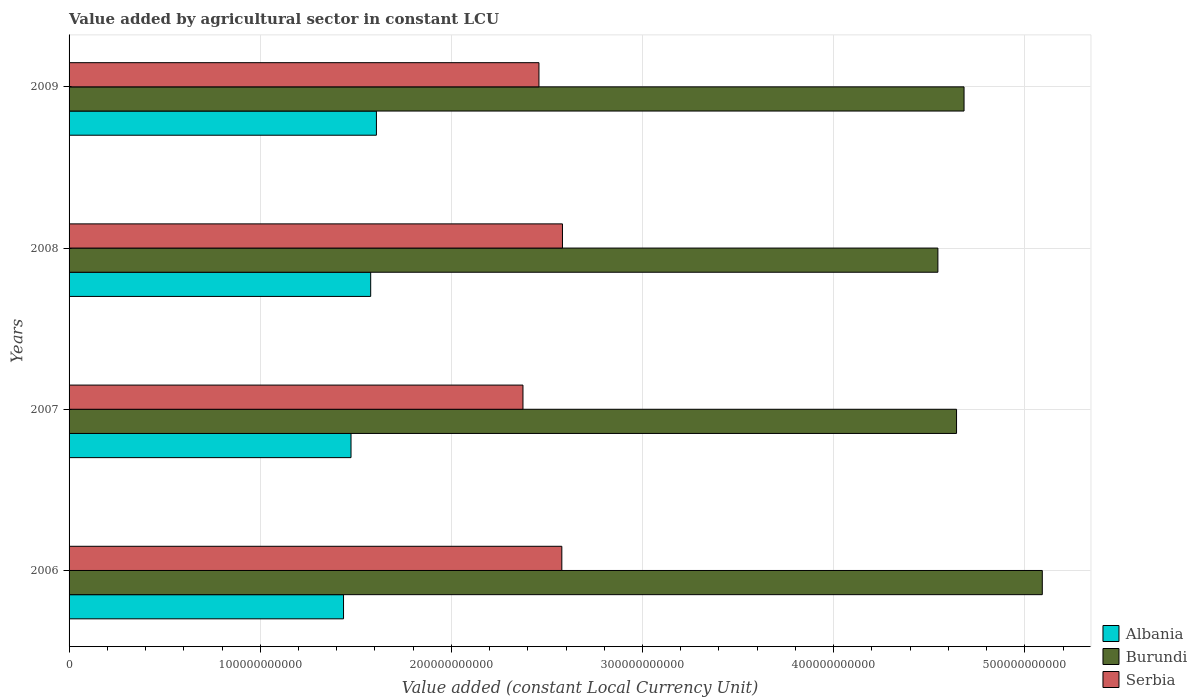How many groups of bars are there?
Your answer should be compact. 4. Are the number of bars per tick equal to the number of legend labels?
Provide a short and direct response. Yes. Are the number of bars on each tick of the Y-axis equal?
Your answer should be very brief. Yes. What is the label of the 2nd group of bars from the top?
Provide a succinct answer. 2008. What is the value added by agricultural sector in Albania in 2009?
Offer a terse response. 1.61e+11. Across all years, what is the maximum value added by agricultural sector in Burundi?
Offer a very short reply. 5.09e+11. Across all years, what is the minimum value added by agricultural sector in Serbia?
Offer a very short reply. 2.37e+11. What is the total value added by agricultural sector in Albania in the graph?
Your response must be concise. 6.10e+11. What is the difference between the value added by agricultural sector in Albania in 2008 and that in 2009?
Provide a short and direct response. -3.00e+09. What is the difference between the value added by agricultural sector in Albania in 2006 and the value added by agricultural sector in Burundi in 2008?
Provide a short and direct response. -3.11e+11. What is the average value added by agricultural sector in Albania per year?
Keep it short and to the point. 1.52e+11. In the year 2007, what is the difference between the value added by agricultural sector in Albania and value added by agricultural sector in Burundi?
Provide a short and direct response. -3.17e+11. In how many years, is the value added by agricultural sector in Albania greater than 280000000000 LCU?
Give a very brief answer. 0. What is the ratio of the value added by agricultural sector in Serbia in 2006 to that in 2009?
Make the answer very short. 1.05. Is the difference between the value added by agricultural sector in Albania in 2007 and 2009 greater than the difference between the value added by agricultural sector in Burundi in 2007 and 2009?
Offer a terse response. No. What is the difference between the highest and the second highest value added by agricultural sector in Serbia?
Your answer should be very brief. 3.31e+08. What is the difference between the highest and the lowest value added by agricultural sector in Burundi?
Your answer should be compact. 5.46e+1. Is the sum of the value added by agricultural sector in Serbia in 2008 and 2009 greater than the maximum value added by agricultural sector in Burundi across all years?
Provide a short and direct response. No. What does the 2nd bar from the top in 2009 represents?
Offer a terse response. Burundi. What does the 1st bar from the bottom in 2008 represents?
Keep it short and to the point. Albania. Is it the case that in every year, the sum of the value added by agricultural sector in Serbia and value added by agricultural sector in Albania is greater than the value added by agricultural sector in Burundi?
Ensure brevity in your answer.  No. Are all the bars in the graph horizontal?
Your answer should be compact. Yes. What is the difference between two consecutive major ticks on the X-axis?
Provide a succinct answer. 1.00e+11. How many legend labels are there?
Provide a short and direct response. 3. What is the title of the graph?
Your answer should be compact. Value added by agricultural sector in constant LCU. What is the label or title of the X-axis?
Give a very brief answer. Value added (constant Local Currency Unit). What is the Value added (constant Local Currency Unit) in Albania in 2006?
Your response must be concise. 1.44e+11. What is the Value added (constant Local Currency Unit) in Burundi in 2006?
Your answer should be very brief. 5.09e+11. What is the Value added (constant Local Currency Unit) in Serbia in 2006?
Offer a terse response. 2.58e+11. What is the Value added (constant Local Currency Unit) in Albania in 2007?
Your response must be concise. 1.48e+11. What is the Value added (constant Local Currency Unit) of Burundi in 2007?
Your answer should be very brief. 4.64e+11. What is the Value added (constant Local Currency Unit) of Serbia in 2007?
Keep it short and to the point. 2.37e+11. What is the Value added (constant Local Currency Unit) of Albania in 2008?
Ensure brevity in your answer.  1.58e+11. What is the Value added (constant Local Currency Unit) of Burundi in 2008?
Ensure brevity in your answer.  4.55e+11. What is the Value added (constant Local Currency Unit) in Serbia in 2008?
Your response must be concise. 2.58e+11. What is the Value added (constant Local Currency Unit) in Albania in 2009?
Your answer should be compact. 1.61e+11. What is the Value added (constant Local Currency Unit) in Burundi in 2009?
Offer a very short reply. 4.68e+11. What is the Value added (constant Local Currency Unit) in Serbia in 2009?
Provide a succinct answer. 2.46e+11. Across all years, what is the maximum Value added (constant Local Currency Unit) in Albania?
Provide a short and direct response. 1.61e+11. Across all years, what is the maximum Value added (constant Local Currency Unit) of Burundi?
Provide a succinct answer. 5.09e+11. Across all years, what is the maximum Value added (constant Local Currency Unit) in Serbia?
Offer a very short reply. 2.58e+11. Across all years, what is the minimum Value added (constant Local Currency Unit) of Albania?
Your answer should be compact. 1.44e+11. Across all years, what is the minimum Value added (constant Local Currency Unit) in Burundi?
Offer a terse response. 4.55e+11. Across all years, what is the minimum Value added (constant Local Currency Unit) in Serbia?
Provide a succinct answer. 2.37e+11. What is the total Value added (constant Local Currency Unit) of Albania in the graph?
Your answer should be very brief. 6.10e+11. What is the total Value added (constant Local Currency Unit) of Burundi in the graph?
Your answer should be compact. 1.90e+12. What is the total Value added (constant Local Currency Unit) of Serbia in the graph?
Keep it short and to the point. 9.99e+11. What is the difference between the Value added (constant Local Currency Unit) in Albania in 2006 and that in 2007?
Your response must be concise. -3.92e+09. What is the difference between the Value added (constant Local Currency Unit) of Burundi in 2006 and that in 2007?
Keep it short and to the point. 4.49e+1. What is the difference between the Value added (constant Local Currency Unit) of Serbia in 2006 and that in 2007?
Ensure brevity in your answer.  2.03e+1. What is the difference between the Value added (constant Local Currency Unit) in Albania in 2006 and that in 2008?
Ensure brevity in your answer.  -1.42e+1. What is the difference between the Value added (constant Local Currency Unit) of Burundi in 2006 and that in 2008?
Ensure brevity in your answer.  5.46e+1. What is the difference between the Value added (constant Local Currency Unit) of Serbia in 2006 and that in 2008?
Your answer should be compact. -3.31e+08. What is the difference between the Value added (constant Local Currency Unit) of Albania in 2006 and that in 2009?
Your answer should be very brief. -1.72e+1. What is the difference between the Value added (constant Local Currency Unit) in Burundi in 2006 and that in 2009?
Your answer should be compact. 4.09e+1. What is the difference between the Value added (constant Local Currency Unit) in Serbia in 2006 and that in 2009?
Your response must be concise. 1.20e+1. What is the difference between the Value added (constant Local Currency Unit) of Albania in 2007 and that in 2008?
Offer a terse response. -1.03e+1. What is the difference between the Value added (constant Local Currency Unit) of Burundi in 2007 and that in 2008?
Offer a terse response. 9.76e+09. What is the difference between the Value added (constant Local Currency Unit) of Serbia in 2007 and that in 2008?
Your response must be concise. -2.07e+1. What is the difference between the Value added (constant Local Currency Unit) in Albania in 2007 and that in 2009?
Your response must be concise. -1.33e+1. What is the difference between the Value added (constant Local Currency Unit) in Burundi in 2007 and that in 2009?
Your answer should be compact. -3.93e+09. What is the difference between the Value added (constant Local Currency Unit) of Serbia in 2007 and that in 2009?
Your answer should be compact. -8.36e+09. What is the difference between the Value added (constant Local Currency Unit) of Albania in 2008 and that in 2009?
Your answer should be compact. -3.00e+09. What is the difference between the Value added (constant Local Currency Unit) of Burundi in 2008 and that in 2009?
Your answer should be very brief. -1.37e+1. What is the difference between the Value added (constant Local Currency Unit) in Serbia in 2008 and that in 2009?
Your answer should be compact. 1.23e+1. What is the difference between the Value added (constant Local Currency Unit) of Albania in 2006 and the Value added (constant Local Currency Unit) of Burundi in 2007?
Offer a very short reply. -3.21e+11. What is the difference between the Value added (constant Local Currency Unit) of Albania in 2006 and the Value added (constant Local Currency Unit) of Serbia in 2007?
Make the answer very short. -9.39e+1. What is the difference between the Value added (constant Local Currency Unit) of Burundi in 2006 and the Value added (constant Local Currency Unit) of Serbia in 2007?
Your response must be concise. 2.72e+11. What is the difference between the Value added (constant Local Currency Unit) in Albania in 2006 and the Value added (constant Local Currency Unit) in Burundi in 2008?
Your response must be concise. -3.11e+11. What is the difference between the Value added (constant Local Currency Unit) in Albania in 2006 and the Value added (constant Local Currency Unit) in Serbia in 2008?
Ensure brevity in your answer.  -1.15e+11. What is the difference between the Value added (constant Local Currency Unit) of Burundi in 2006 and the Value added (constant Local Currency Unit) of Serbia in 2008?
Give a very brief answer. 2.51e+11. What is the difference between the Value added (constant Local Currency Unit) of Albania in 2006 and the Value added (constant Local Currency Unit) of Burundi in 2009?
Provide a short and direct response. -3.25e+11. What is the difference between the Value added (constant Local Currency Unit) in Albania in 2006 and the Value added (constant Local Currency Unit) in Serbia in 2009?
Provide a succinct answer. -1.02e+11. What is the difference between the Value added (constant Local Currency Unit) in Burundi in 2006 and the Value added (constant Local Currency Unit) in Serbia in 2009?
Provide a succinct answer. 2.63e+11. What is the difference between the Value added (constant Local Currency Unit) in Albania in 2007 and the Value added (constant Local Currency Unit) in Burundi in 2008?
Make the answer very short. -3.07e+11. What is the difference between the Value added (constant Local Currency Unit) in Albania in 2007 and the Value added (constant Local Currency Unit) in Serbia in 2008?
Provide a succinct answer. -1.11e+11. What is the difference between the Value added (constant Local Currency Unit) of Burundi in 2007 and the Value added (constant Local Currency Unit) of Serbia in 2008?
Ensure brevity in your answer.  2.06e+11. What is the difference between the Value added (constant Local Currency Unit) of Albania in 2007 and the Value added (constant Local Currency Unit) of Burundi in 2009?
Provide a short and direct response. -3.21e+11. What is the difference between the Value added (constant Local Currency Unit) in Albania in 2007 and the Value added (constant Local Currency Unit) in Serbia in 2009?
Provide a succinct answer. -9.83e+1. What is the difference between the Value added (constant Local Currency Unit) in Burundi in 2007 and the Value added (constant Local Currency Unit) in Serbia in 2009?
Your response must be concise. 2.18e+11. What is the difference between the Value added (constant Local Currency Unit) of Albania in 2008 and the Value added (constant Local Currency Unit) of Burundi in 2009?
Provide a succinct answer. -3.10e+11. What is the difference between the Value added (constant Local Currency Unit) of Albania in 2008 and the Value added (constant Local Currency Unit) of Serbia in 2009?
Ensure brevity in your answer.  -8.80e+1. What is the difference between the Value added (constant Local Currency Unit) of Burundi in 2008 and the Value added (constant Local Currency Unit) of Serbia in 2009?
Offer a terse response. 2.09e+11. What is the average Value added (constant Local Currency Unit) in Albania per year?
Make the answer very short. 1.52e+11. What is the average Value added (constant Local Currency Unit) in Burundi per year?
Your answer should be very brief. 4.74e+11. What is the average Value added (constant Local Currency Unit) in Serbia per year?
Keep it short and to the point. 2.50e+11. In the year 2006, what is the difference between the Value added (constant Local Currency Unit) in Albania and Value added (constant Local Currency Unit) in Burundi?
Give a very brief answer. -3.66e+11. In the year 2006, what is the difference between the Value added (constant Local Currency Unit) in Albania and Value added (constant Local Currency Unit) in Serbia?
Provide a succinct answer. -1.14e+11. In the year 2006, what is the difference between the Value added (constant Local Currency Unit) of Burundi and Value added (constant Local Currency Unit) of Serbia?
Your response must be concise. 2.51e+11. In the year 2007, what is the difference between the Value added (constant Local Currency Unit) in Albania and Value added (constant Local Currency Unit) in Burundi?
Provide a short and direct response. -3.17e+11. In the year 2007, what is the difference between the Value added (constant Local Currency Unit) of Albania and Value added (constant Local Currency Unit) of Serbia?
Keep it short and to the point. -9.00e+1. In the year 2007, what is the difference between the Value added (constant Local Currency Unit) in Burundi and Value added (constant Local Currency Unit) in Serbia?
Provide a succinct answer. 2.27e+11. In the year 2008, what is the difference between the Value added (constant Local Currency Unit) of Albania and Value added (constant Local Currency Unit) of Burundi?
Your answer should be very brief. -2.97e+11. In the year 2008, what is the difference between the Value added (constant Local Currency Unit) of Albania and Value added (constant Local Currency Unit) of Serbia?
Your answer should be very brief. -1.00e+11. In the year 2008, what is the difference between the Value added (constant Local Currency Unit) of Burundi and Value added (constant Local Currency Unit) of Serbia?
Your response must be concise. 1.96e+11. In the year 2009, what is the difference between the Value added (constant Local Currency Unit) of Albania and Value added (constant Local Currency Unit) of Burundi?
Make the answer very short. -3.07e+11. In the year 2009, what is the difference between the Value added (constant Local Currency Unit) in Albania and Value added (constant Local Currency Unit) in Serbia?
Offer a terse response. -8.50e+1. In the year 2009, what is the difference between the Value added (constant Local Currency Unit) in Burundi and Value added (constant Local Currency Unit) in Serbia?
Offer a very short reply. 2.22e+11. What is the ratio of the Value added (constant Local Currency Unit) in Albania in 2006 to that in 2007?
Offer a very short reply. 0.97. What is the ratio of the Value added (constant Local Currency Unit) in Burundi in 2006 to that in 2007?
Offer a very short reply. 1.1. What is the ratio of the Value added (constant Local Currency Unit) in Serbia in 2006 to that in 2007?
Your answer should be very brief. 1.09. What is the ratio of the Value added (constant Local Currency Unit) in Albania in 2006 to that in 2008?
Make the answer very short. 0.91. What is the ratio of the Value added (constant Local Currency Unit) in Burundi in 2006 to that in 2008?
Your answer should be very brief. 1.12. What is the ratio of the Value added (constant Local Currency Unit) of Albania in 2006 to that in 2009?
Give a very brief answer. 0.89. What is the ratio of the Value added (constant Local Currency Unit) in Burundi in 2006 to that in 2009?
Your answer should be very brief. 1.09. What is the ratio of the Value added (constant Local Currency Unit) of Serbia in 2006 to that in 2009?
Your answer should be compact. 1.05. What is the ratio of the Value added (constant Local Currency Unit) in Albania in 2007 to that in 2008?
Offer a very short reply. 0.93. What is the ratio of the Value added (constant Local Currency Unit) in Burundi in 2007 to that in 2008?
Offer a very short reply. 1.02. What is the ratio of the Value added (constant Local Currency Unit) of Serbia in 2007 to that in 2008?
Give a very brief answer. 0.92. What is the ratio of the Value added (constant Local Currency Unit) of Albania in 2007 to that in 2009?
Provide a short and direct response. 0.92. What is the ratio of the Value added (constant Local Currency Unit) in Serbia in 2007 to that in 2009?
Keep it short and to the point. 0.97. What is the ratio of the Value added (constant Local Currency Unit) in Albania in 2008 to that in 2009?
Your answer should be compact. 0.98. What is the ratio of the Value added (constant Local Currency Unit) in Burundi in 2008 to that in 2009?
Offer a very short reply. 0.97. What is the ratio of the Value added (constant Local Currency Unit) of Serbia in 2008 to that in 2009?
Ensure brevity in your answer.  1.05. What is the difference between the highest and the second highest Value added (constant Local Currency Unit) of Albania?
Provide a short and direct response. 3.00e+09. What is the difference between the highest and the second highest Value added (constant Local Currency Unit) in Burundi?
Keep it short and to the point. 4.09e+1. What is the difference between the highest and the second highest Value added (constant Local Currency Unit) in Serbia?
Provide a succinct answer. 3.31e+08. What is the difference between the highest and the lowest Value added (constant Local Currency Unit) in Albania?
Your response must be concise. 1.72e+1. What is the difference between the highest and the lowest Value added (constant Local Currency Unit) in Burundi?
Provide a succinct answer. 5.46e+1. What is the difference between the highest and the lowest Value added (constant Local Currency Unit) of Serbia?
Keep it short and to the point. 2.07e+1. 